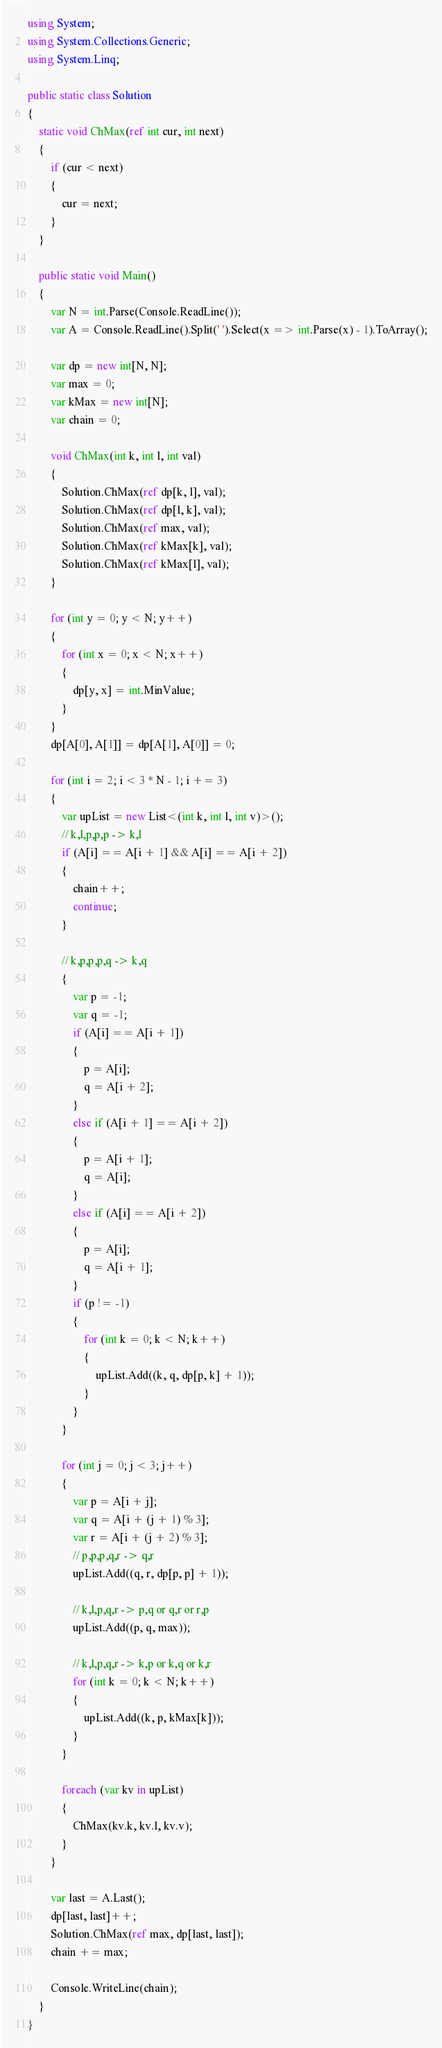Convert code to text. <code><loc_0><loc_0><loc_500><loc_500><_C#_>using System;
using System.Collections.Generic;
using System.Linq;

public static class Solution
{
    static void ChMax(ref int cur, int next)
    {
        if (cur < next)
        {
            cur = next;
        }
    }

    public static void Main()
    {
        var N = int.Parse(Console.ReadLine());
        var A = Console.ReadLine().Split(' ').Select(x => int.Parse(x) - 1).ToArray();

        var dp = new int[N, N];
        var max = 0;
        var kMax = new int[N];
        var chain = 0;

        void ChMax(int k, int l, int val)
        {
            Solution.ChMax(ref dp[k, l], val);
            Solution.ChMax(ref dp[l, k], val);
            Solution.ChMax(ref max, val);
            Solution.ChMax(ref kMax[k], val);
            Solution.ChMax(ref kMax[l], val);
        }

        for (int y = 0; y < N; y++)
        {
            for (int x = 0; x < N; x++)
            {
                dp[y, x] = int.MinValue;
            }
        }
        dp[A[0], A[1]] = dp[A[1], A[0]] = 0;

        for (int i = 2; i < 3 * N - 1; i += 3)
        {
            var upList = new List<(int k, int l, int v)>();
            // k,l,p,p,p -> k,l
            if (A[i] == A[i + 1] && A[i] == A[i + 2])
            {
                chain++;
                continue;
            }

            // k,p,p,p,q -> k,q
            {
                var p = -1;
                var q = -1;
                if (A[i] == A[i + 1])
                {
                    p = A[i];
                    q = A[i + 2];
                }
                else if (A[i + 1] == A[i + 2])
                {
                    p = A[i + 1];
                    q = A[i];
                }
                else if (A[i] == A[i + 2])
                {
                    p = A[i];
                    q = A[i + 1];
                }
                if (p != -1)
                {
                    for (int k = 0; k < N; k++)
                    {
                        upList.Add((k, q, dp[p, k] + 1));
                    }
                }
            }

            for (int j = 0; j < 3; j++)
            {
                var p = A[i + j];
                var q = A[i + (j + 1) % 3];
                var r = A[i + (j + 2) % 3];
                // p,p,p,q,r -> q,r
                upList.Add((q, r, dp[p, p] + 1));

                // k,l,p,q,r -> p,q or q,r or r,p
                upList.Add((p, q, max));

                // k,l,p,q,r -> k,p or k,q or k,r
                for (int k = 0; k < N; k++)
                {
                    upList.Add((k, p, kMax[k]));
                }
            }

            foreach (var kv in upList)
            {
                ChMax(kv.k, kv.l, kv.v);
            }
        }

        var last = A.Last();
        dp[last, last]++;
        Solution.ChMax(ref max, dp[last, last]);
        chain += max;

        Console.WriteLine(chain);
    }
}</code> 